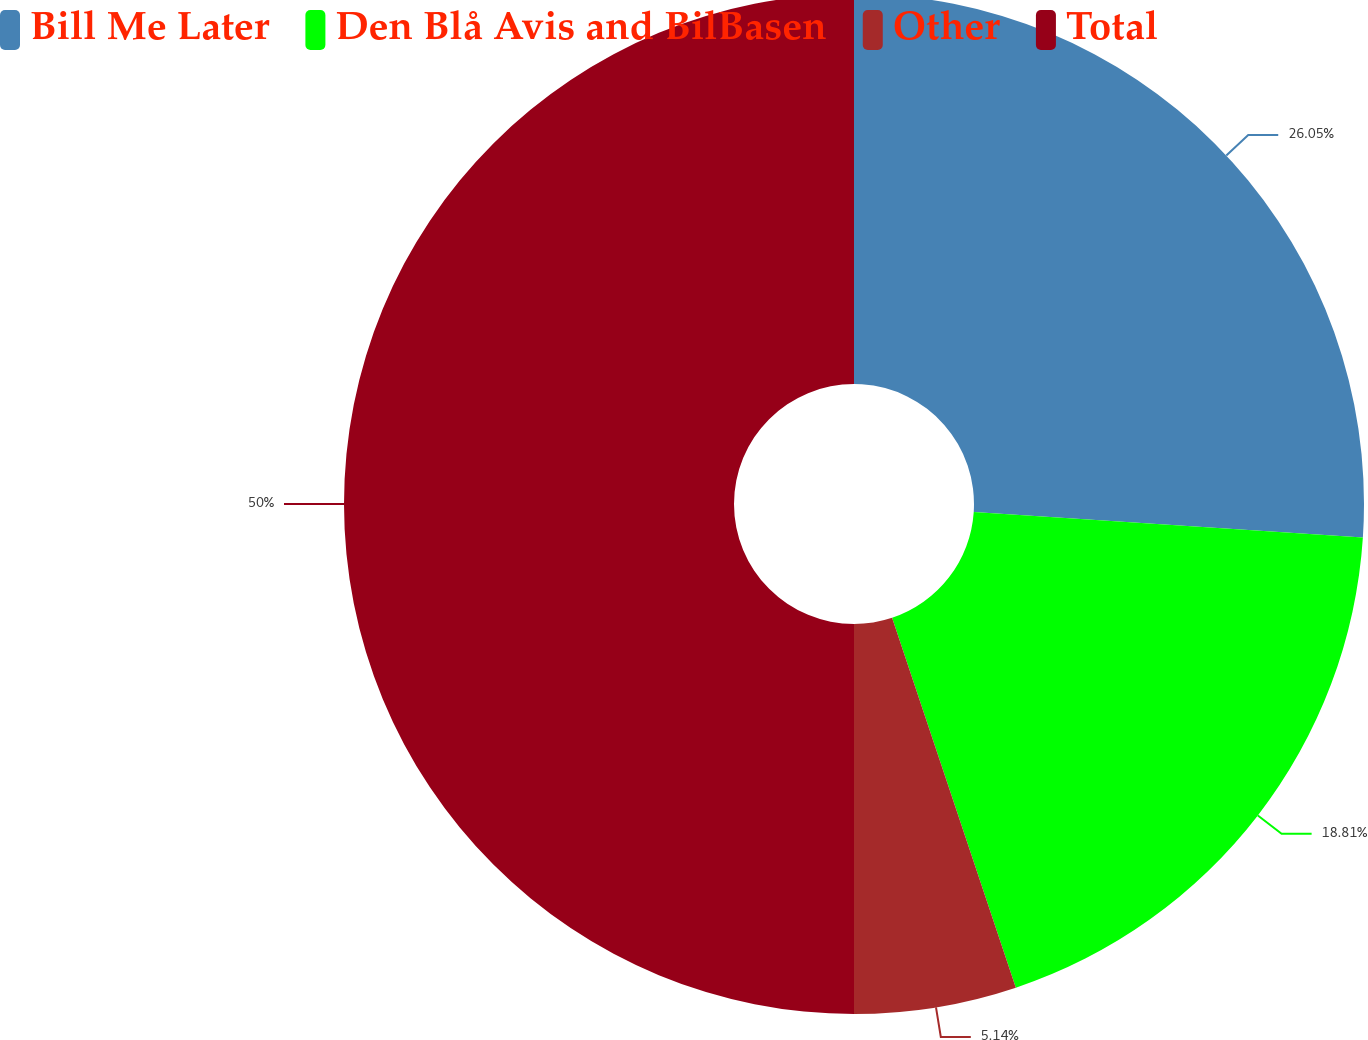<chart> <loc_0><loc_0><loc_500><loc_500><pie_chart><fcel>Bill Me Later<fcel>Den Blå Avis and BilBasen<fcel>Other<fcel>Total<nl><fcel>26.05%<fcel>18.81%<fcel>5.14%<fcel>50.0%<nl></chart> 